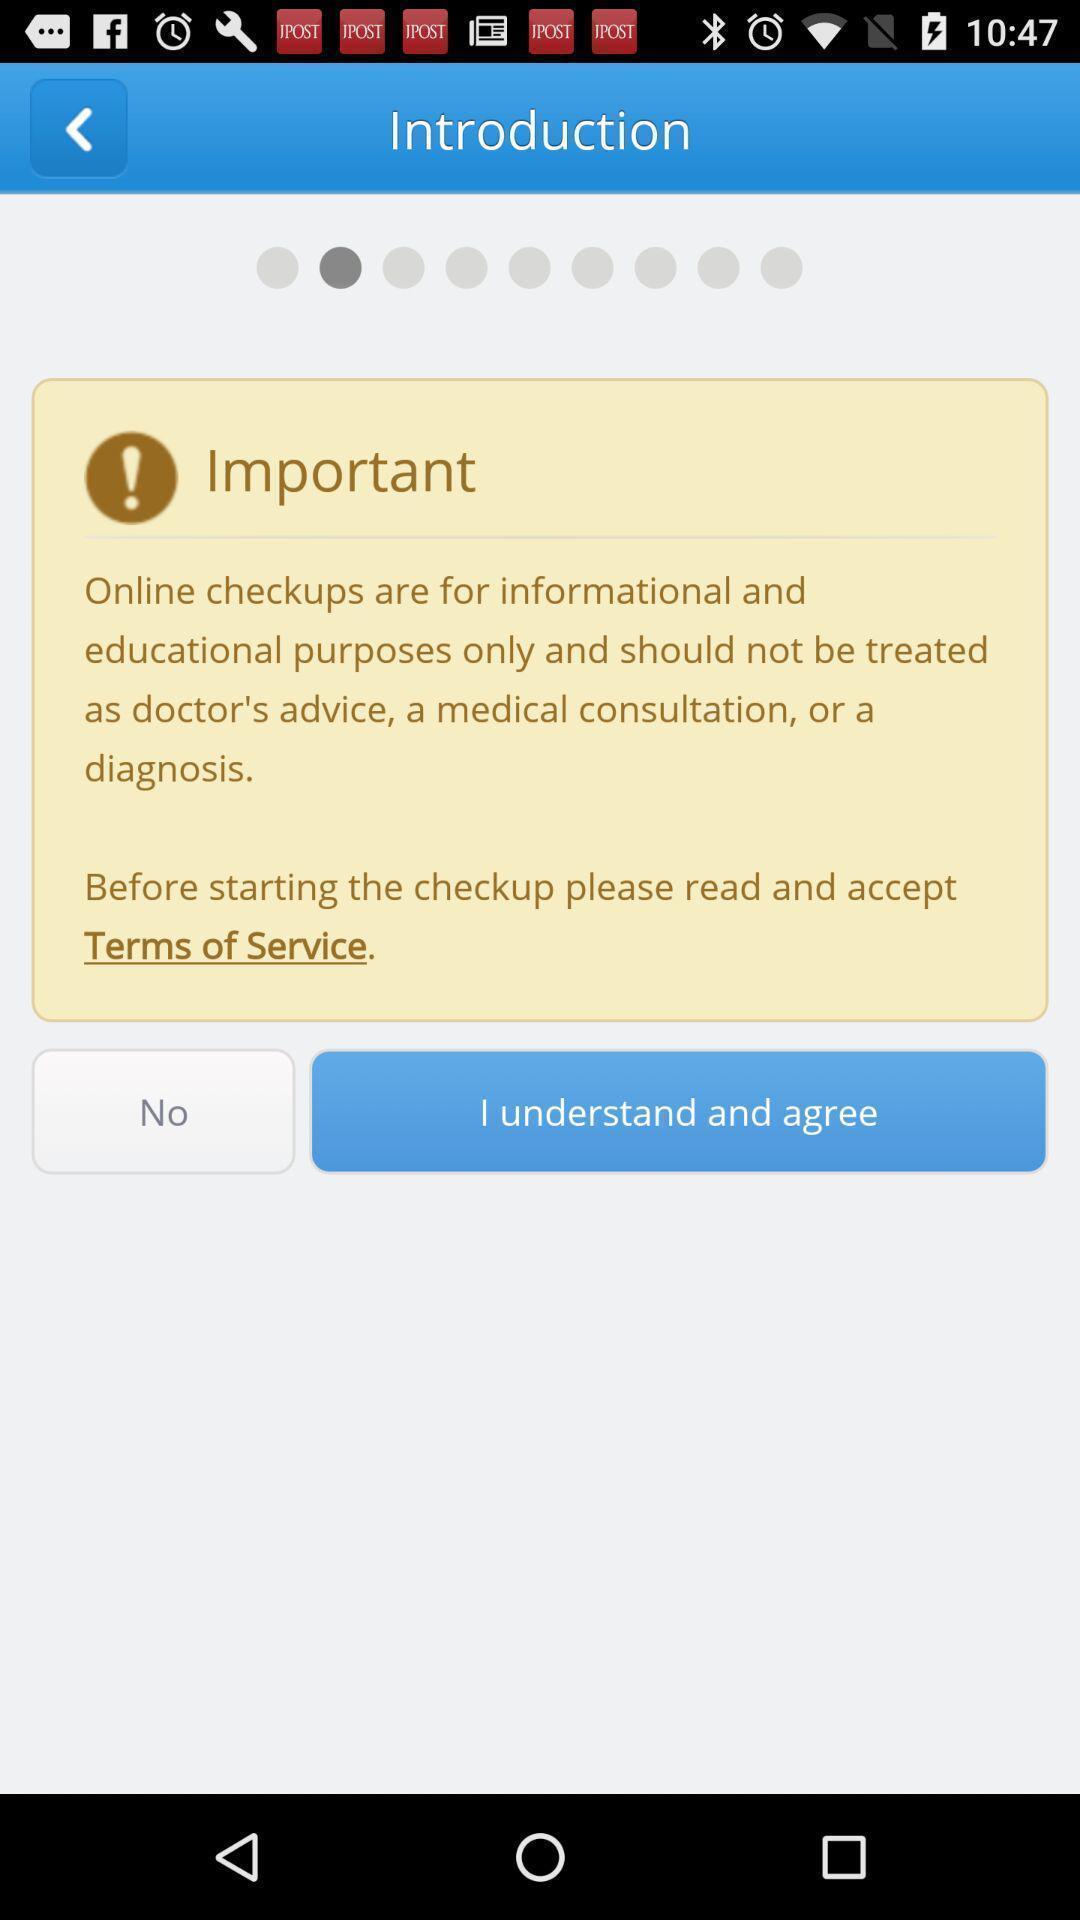What is the overall content of this screenshot? Welcome page with the information about an application. 